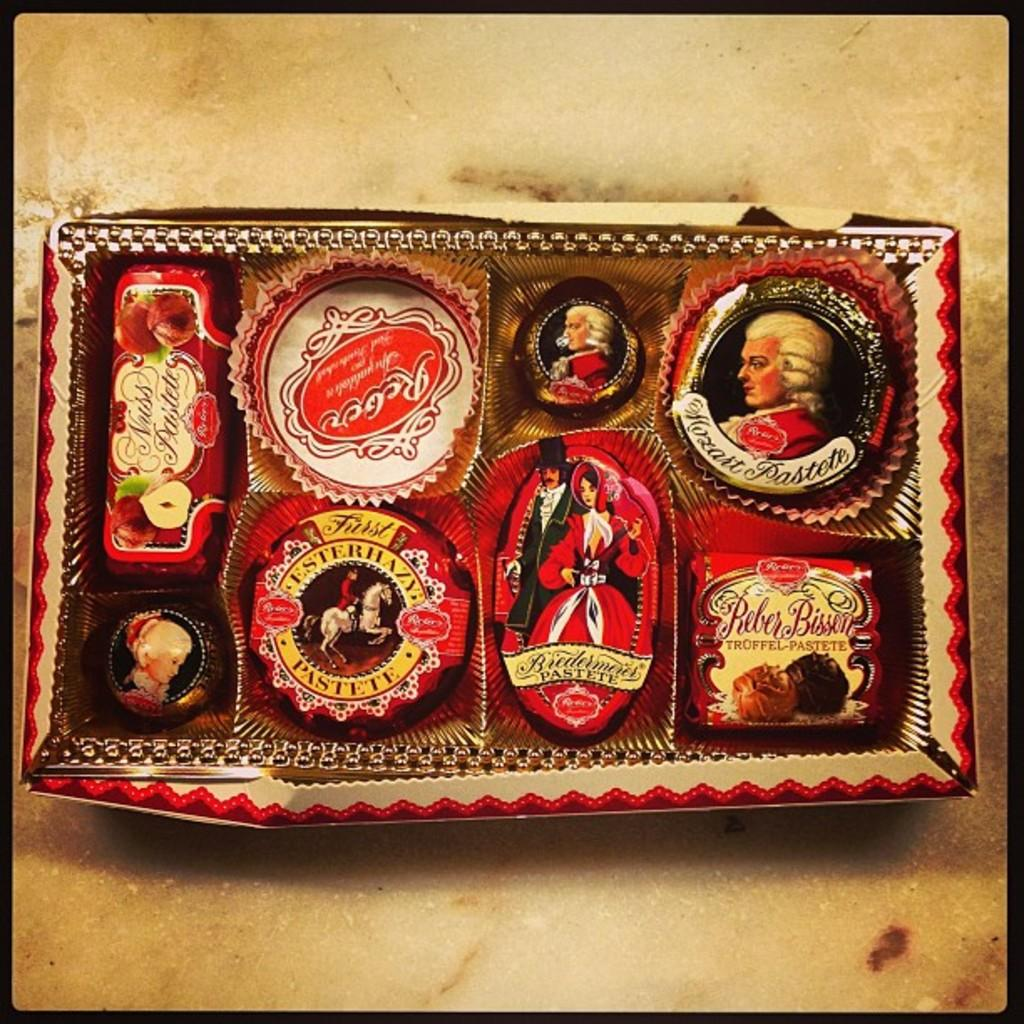What can be seen in the image? There is a frame in the image. Where is the frame located? The frame is placed on a surface. What type of fan is visible in the image? There is no fan present in the image; it only features a frame placed on a surface. What country is the duck from in the image? There is no duck present in the image, so it is not possible to determine the country of origin for a duck. 